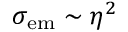Convert formula to latex. <formula><loc_0><loc_0><loc_500><loc_500>\sigma _ { e m } \sim \eta ^ { 2 }</formula> 